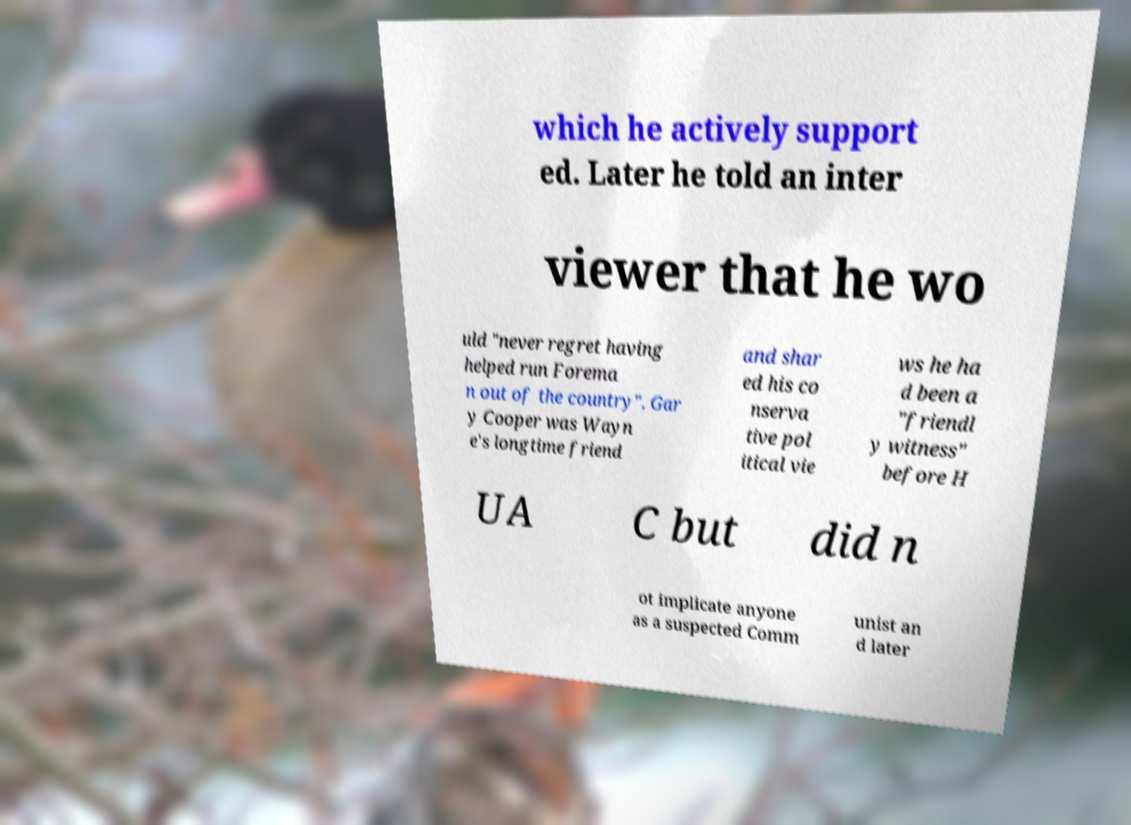I need the written content from this picture converted into text. Can you do that? which he actively support ed. Later he told an inter viewer that he wo uld "never regret having helped run Forema n out of the country". Gar y Cooper was Wayn e's longtime friend and shar ed his co nserva tive pol itical vie ws he ha d been a "friendl y witness" before H UA C but did n ot implicate anyone as a suspected Comm unist an d later 